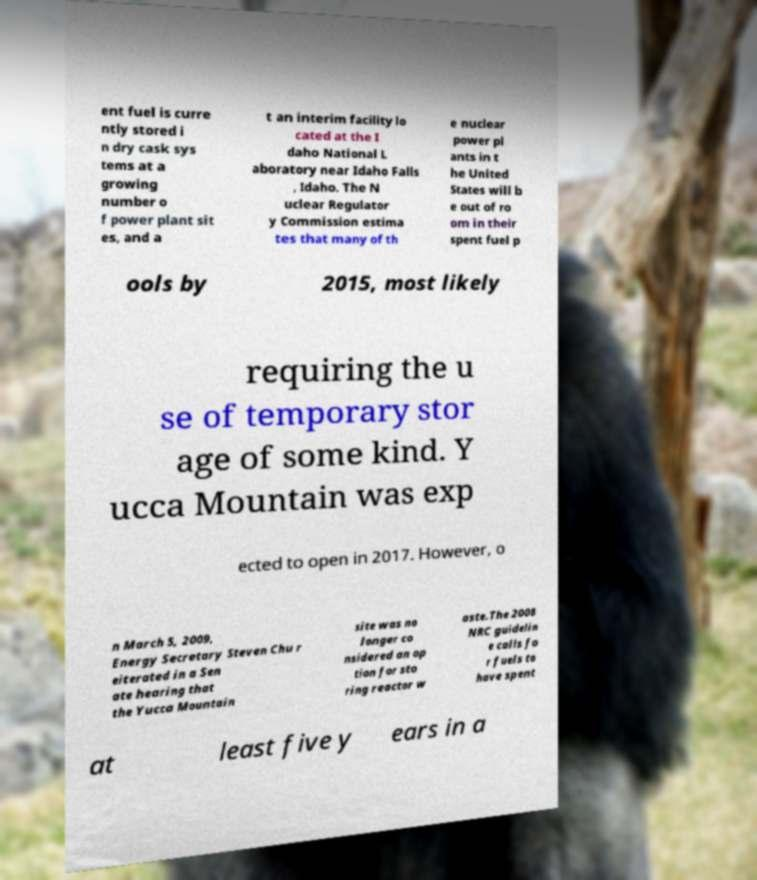Please read and relay the text visible in this image. What does it say? ent fuel is curre ntly stored i n dry cask sys tems at a growing number o f power plant sit es, and a t an interim facility lo cated at the I daho National L aboratory near Idaho Falls , Idaho. The N uclear Regulator y Commission estima tes that many of th e nuclear power pl ants in t he United States will b e out of ro om in their spent fuel p ools by 2015, most likely requiring the u se of temporary stor age of some kind. Y ucca Mountain was exp ected to open in 2017. However, o n March 5, 2009, Energy Secretary Steven Chu r eiterated in a Sen ate hearing that the Yucca Mountain site was no longer co nsidered an op tion for sto ring reactor w aste.The 2008 NRC guidelin e calls fo r fuels to have spent at least five y ears in a 